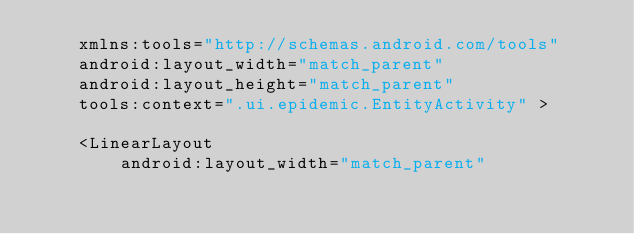<code> <loc_0><loc_0><loc_500><loc_500><_XML_>    xmlns:tools="http://schemas.android.com/tools"
    android:layout_width="match_parent"
    android:layout_height="match_parent"
    tools:context=".ui.epidemic.EntityActivity" >

    <LinearLayout
        android:layout_width="match_parent"</code> 